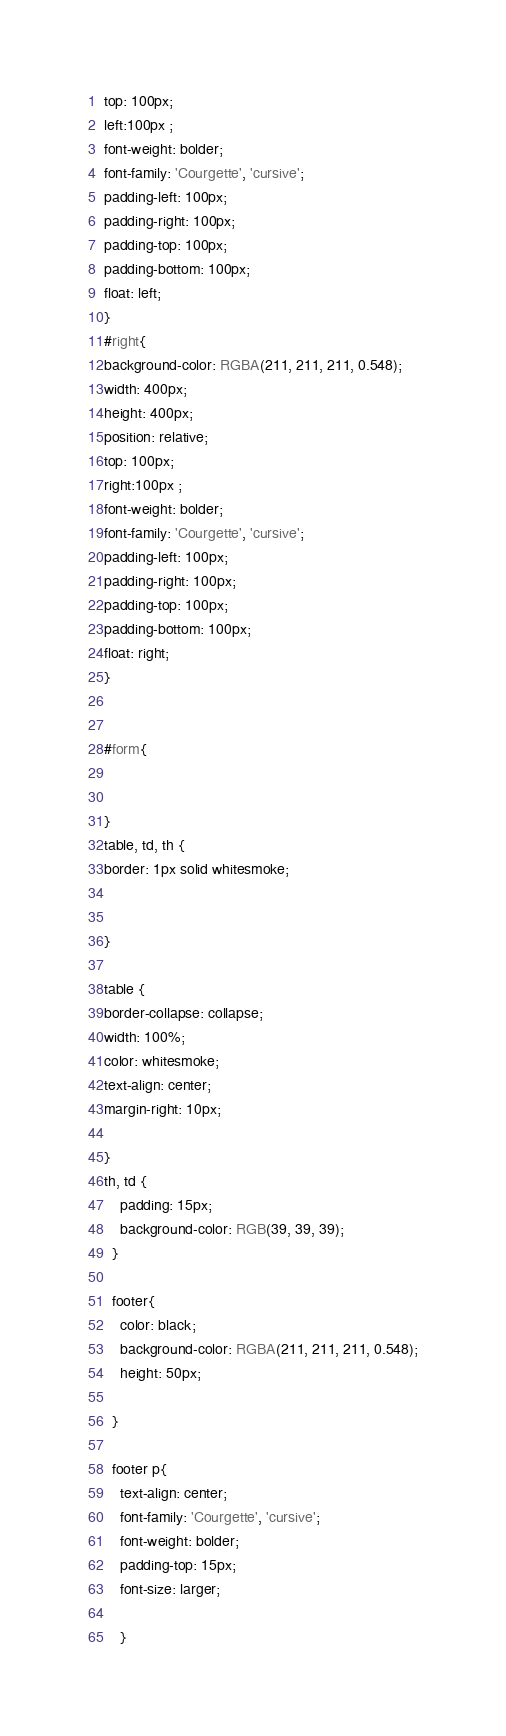Convert code to text. <code><loc_0><loc_0><loc_500><loc_500><_CSS_>top: 100px;
left:100px ;
font-weight: bolder;
font-family: 'Courgette', 'cursive';
padding-left: 100px;
padding-right: 100px;
padding-top: 100px;
padding-bottom: 100px;
float: left;
}
#right{
background-color: RGBA(211, 211, 211, 0.548);  
width: 400px;
height: 400px;
position: relative;
top: 100px;
right:100px ;
font-weight: bolder;
font-family: 'Courgette', 'cursive';
padding-left: 100px;
padding-right: 100px;
padding-top: 100px;
padding-bottom: 100px;
float: right;
}


#form{

    
}
table, td, th {
border: 1px solid whitesmoke;


}

table {
border-collapse: collapse;
width: 100%;
color: whitesmoke;
text-align: center;
margin-right: 10px;

}
th, td {
    padding: 15px;
    background-color: RGB(39, 39, 39);
  }

  footer{
    color: black;
    background-color: RGBA(211, 211, 211, 0.548);
    height: 50px;

  }

  footer p{
    text-align: center;
    font-family: 'Courgette', 'cursive';
    font-weight: bolder;
    padding-top: 15px;
    font-size: larger;
    
    }</code> 